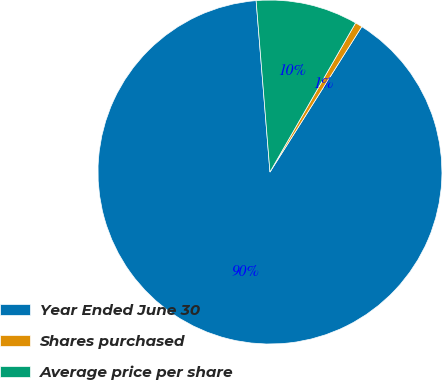Convert chart. <chart><loc_0><loc_0><loc_500><loc_500><pie_chart><fcel>Year Ended June 30<fcel>Shares purchased<fcel>Average price per share<nl><fcel>89.76%<fcel>0.67%<fcel>9.58%<nl></chart> 